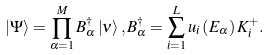Convert formula to latex. <formula><loc_0><loc_0><loc_500><loc_500>\left | \Psi \right \rangle = \prod _ { \alpha = 1 } ^ { M } B _ { \alpha } ^ { \dagger } \left | \nu \right \rangle , B _ { \alpha } ^ { \dagger } = \sum _ { i = 1 } ^ { L } u _ { i } \left ( E _ { \alpha } \right ) K _ { i } ^ { + } .</formula> 